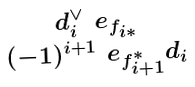Convert formula to latex. <formula><loc_0><loc_0><loc_500><loc_500>\begin{smallmatrix} d _ { i } ^ { \vee } \ e _ { f _ { i * } } \\ ( - 1 ) ^ { i + 1 } \ e _ { f ^ { * } _ { i + 1 } } d _ { i } \end{smallmatrix}</formula> 